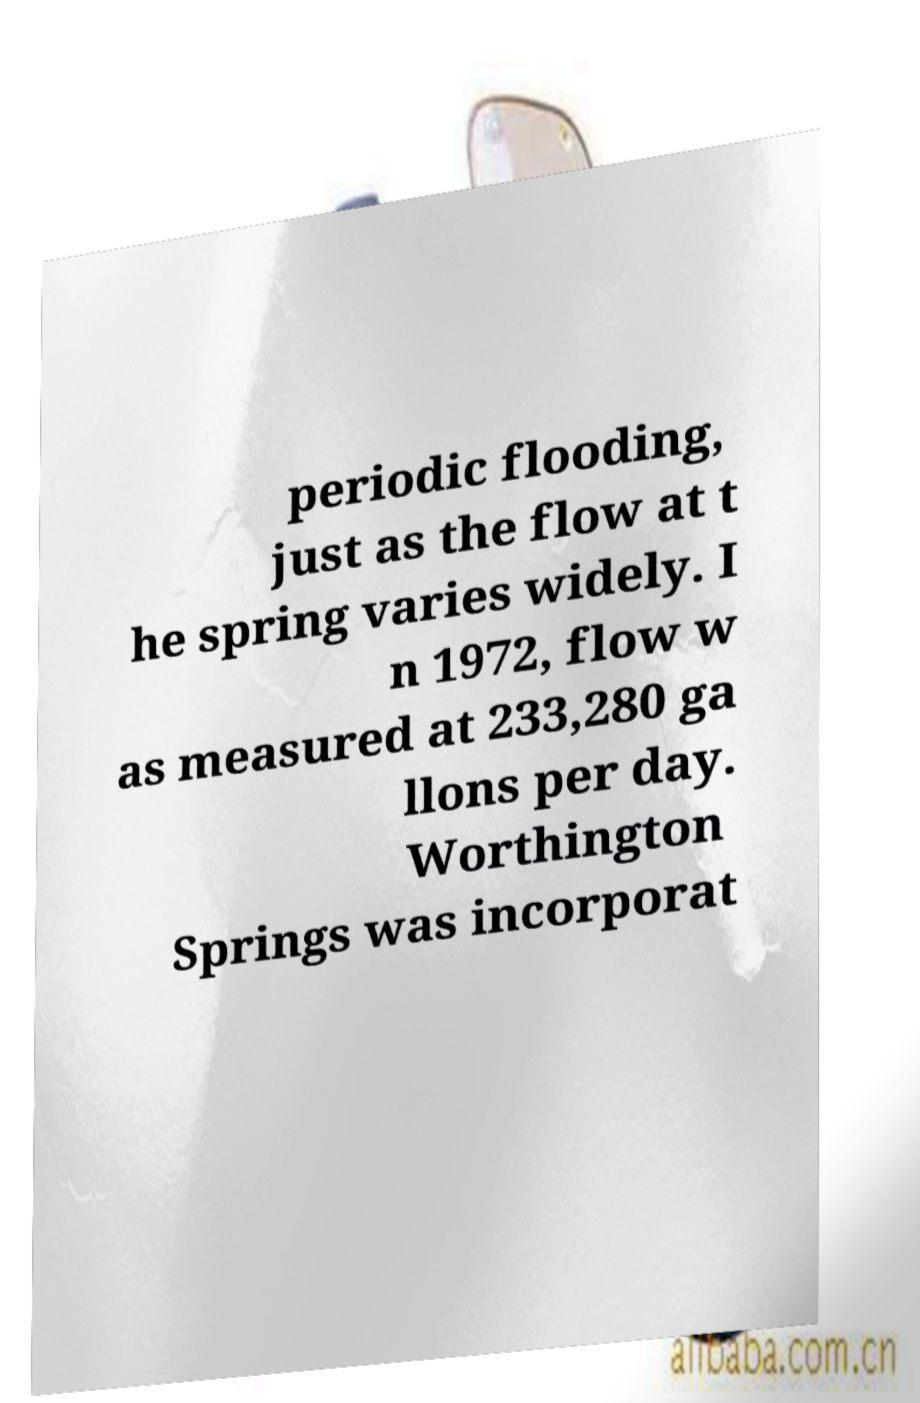There's text embedded in this image that I need extracted. Can you transcribe it verbatim? periodic flooding, just as the flow at t he spring varies widely. I n 1972, flow w as measured at 233,280 ga llons per day. Worthington Springs was incorporat 